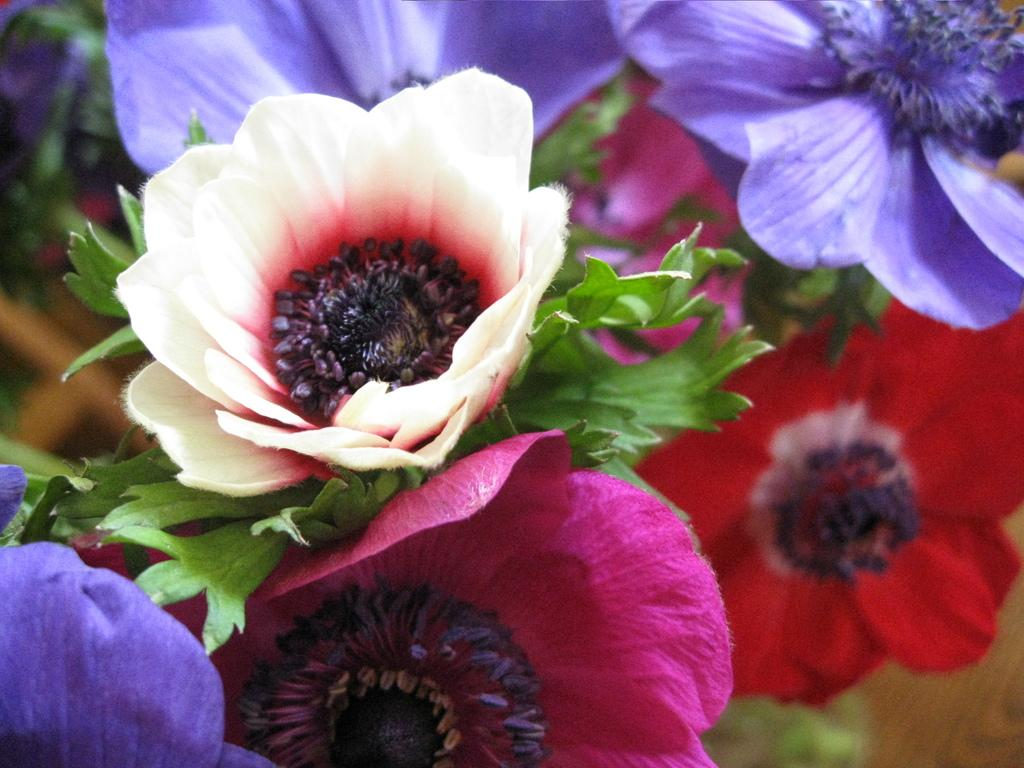What type of plants can be seen in the image? There are colorful flowers in the image. What other parts of the flowers are visible besides the petals? The flowers have leaves. What type of cloth is being used to smash the flowers in the image? There is no cloth or smashing action present in the image; it features colorful flowers with leaves. 